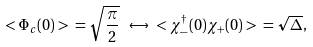<formula> <loc_0><loc_0><loc_500><loc_500>< \Phi _ { c } ( 0 ) > \ = \sqrt { \frac { \pi } { 2 } } \ \leftrightarrow \ < \chi ^ { \dag } _ { - } ( 0 ) \chi _ { + } ( 0 ) > \ = \sqrt { \Delta } ,</formula> 